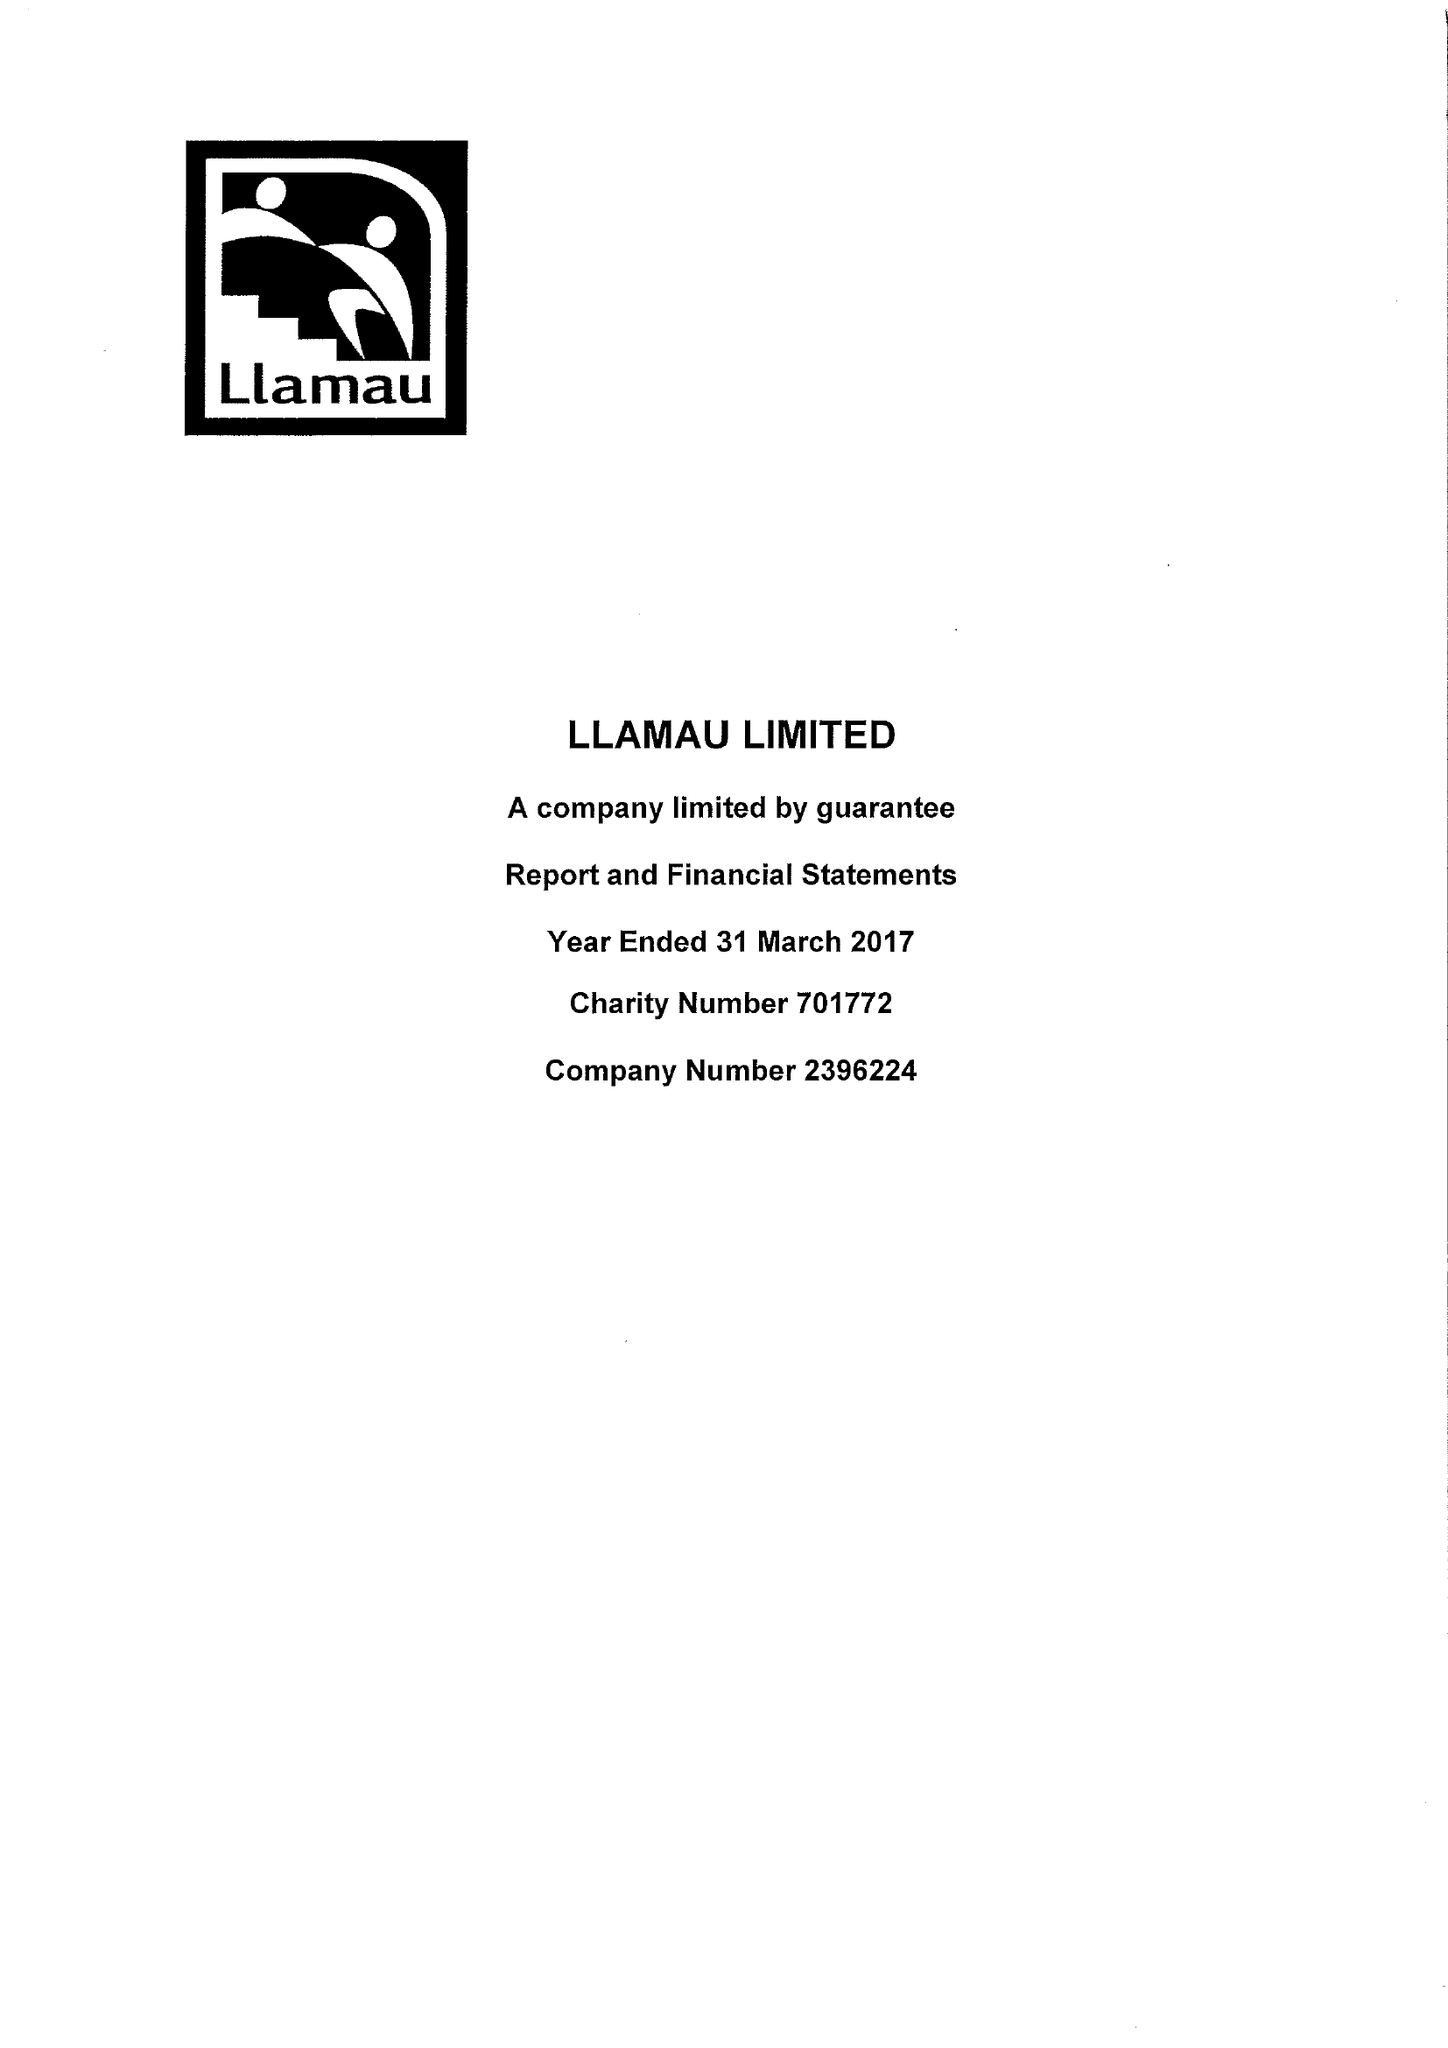What is the value for the income_annually_in_british_pounds?
Answer the question using a single word or phrase. 10297922.00 